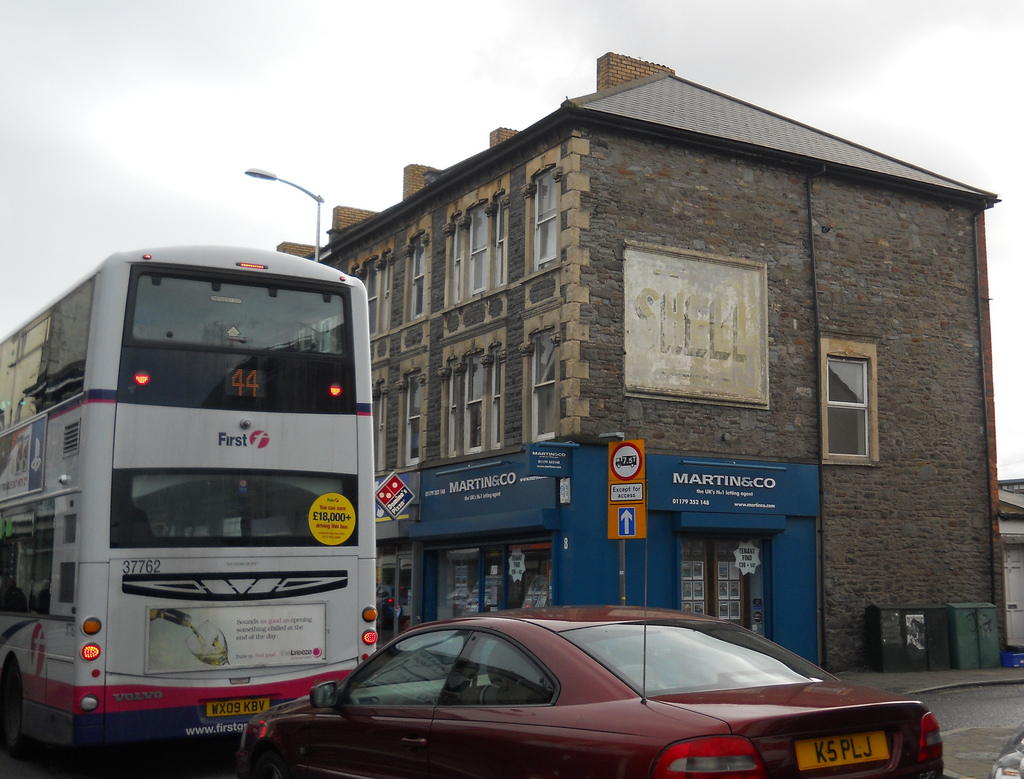Please provide a short description for this region: [0.78, 0.83, 0.87, 0.87]. This region, marked by the coordinates [0.78, 0.83, 0.87, 0.87], describes the location of the car's license plate, providing a clear identification of this component. 